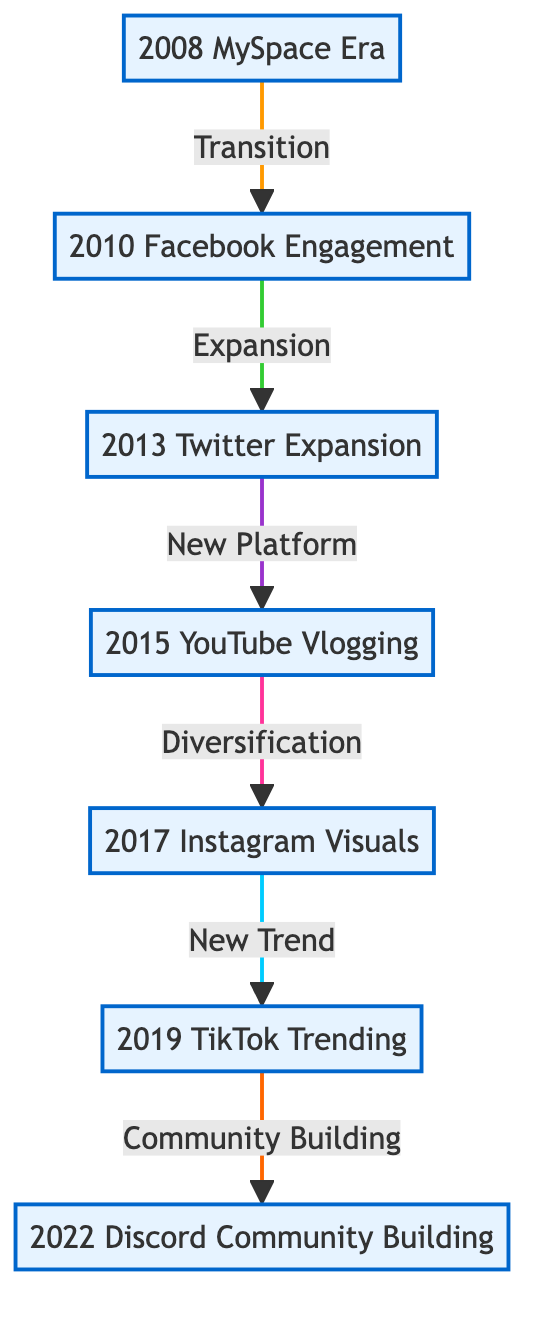What is the first social media platform Austin used? The diagram shows the first node labeled "2008 MySpace Era," which indicates that Austin Haynes started his social media journey with MySpace.
Answer: MySpace How many social media platforms are represented in the diagram? By counting the nodes in the diagram, we can see there are a total of 7 nodes that represent different social media platforms over the years.
Answer: 7 What was the relationship between Twitter and YouTube? The diagram illustrates a link from "2013 Twitter Expansion" to "2015 YouTube Vlogging," labeled "New Platform," indicating that the transition from Twitter to YouTube was considered an expansion to a new platform.
Answer: New Platform Which platform did Austin transition to after MySpace? The diagram shows a direct link from "2008 MySpace Era" to "2010 Facebook Engagement," indicating that after MySpace, he transitioned to Facebook.
Answer: Facebook What change occurred between Instagram and TikTok? The link from "2017 Instagram Visuals" to "2019 TikTok Trending" is labeled "New Trend," suggesting that the change from Instagram to TikTok was driven by a new trend in social media engagement.
Answer: New Trend What kind of community did Austin build on Discord? The last node "2022 Discord Community Building" is linked from "2019 TikTok Trending" with the label "Community Building," which means that the focus on Discord was to foster community among fans.
Answer: Community What is the relationship between Facebook and Twitter? There is an arrow in the diagram from "2010 Facebook Engagement" to "2013 Twitter Expansion," with the relationship labeled "Expansion," indicating that the move from Facebook to Twitter was an expansion of Austin's social media presence.
Answer: Expansion Which platform did Austin start using in 2015? The node labeled "2015 YouTube Vlogging" signifies that in 2015, Austin launched a YouTube channel.
Answer: YouTube 